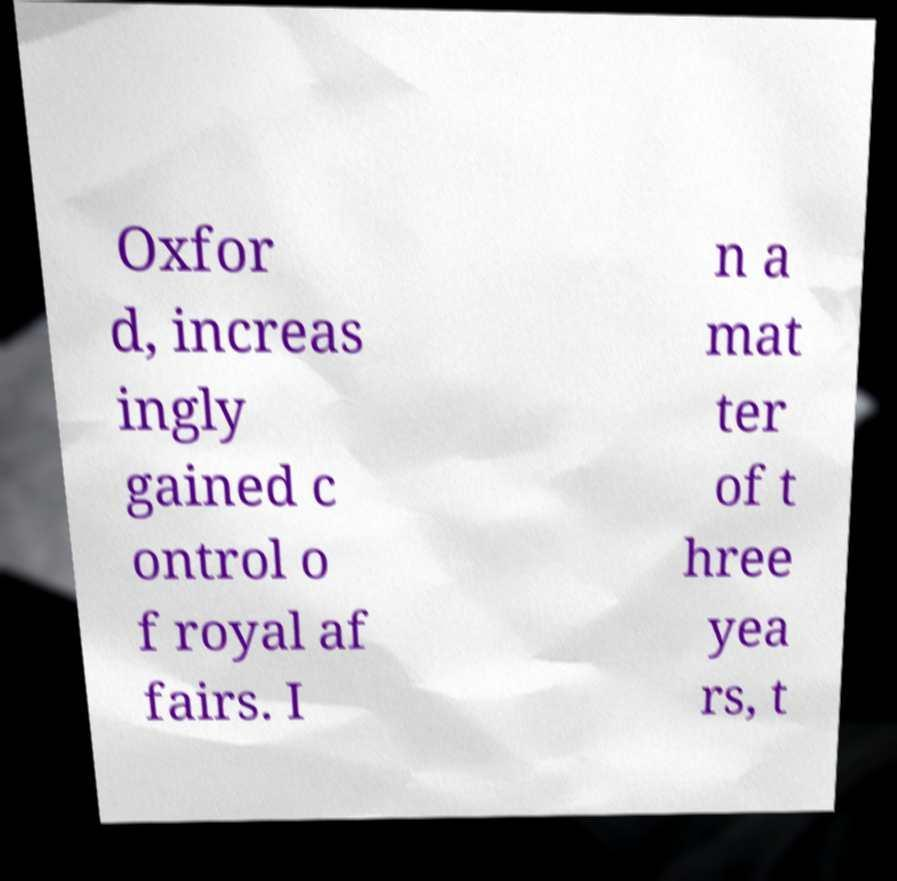For documentation purposes, I need the text within this image transcribed. Could you provide that? Oxfor d, increas ingly gained c ontrol o f royal af fairs. I n a mat ter of t hree yea rs, t 